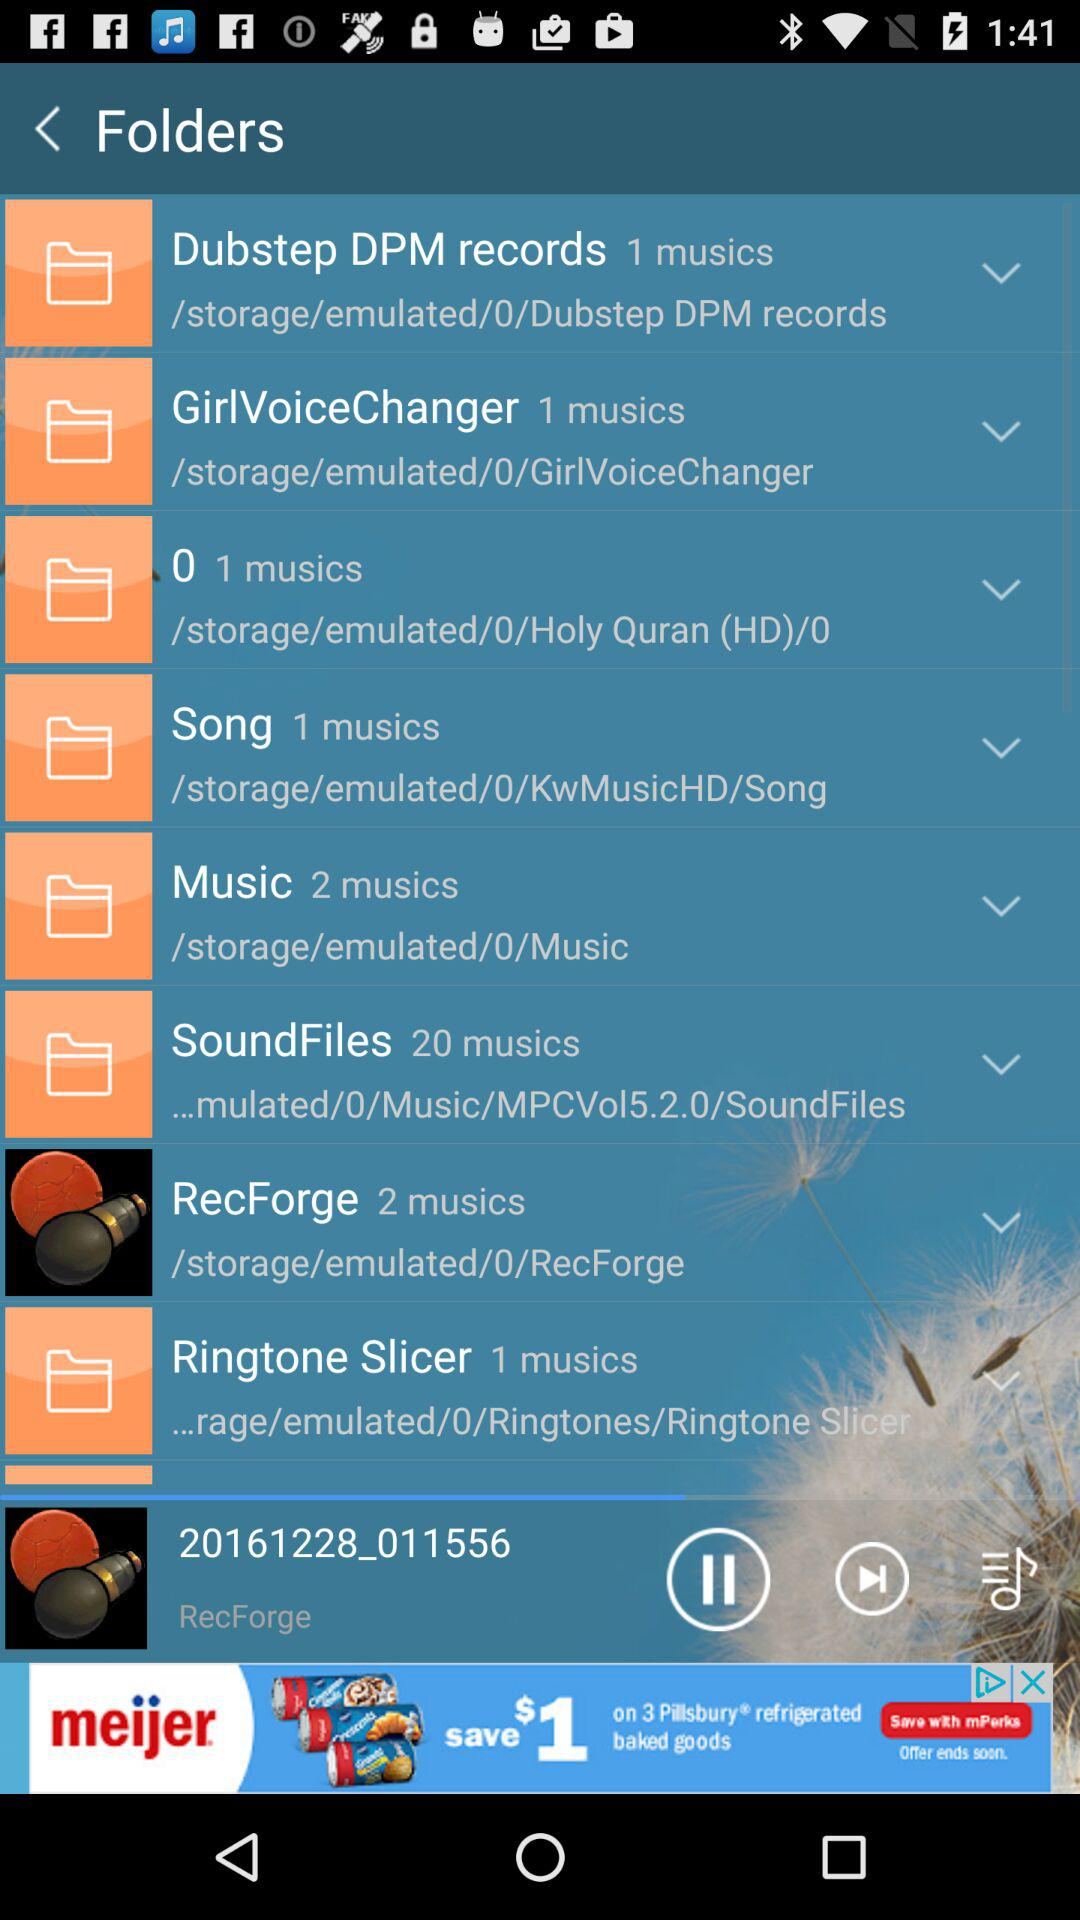How many musics are in the folder with the most musics?
Answer the question using a single word or phrase. 20 